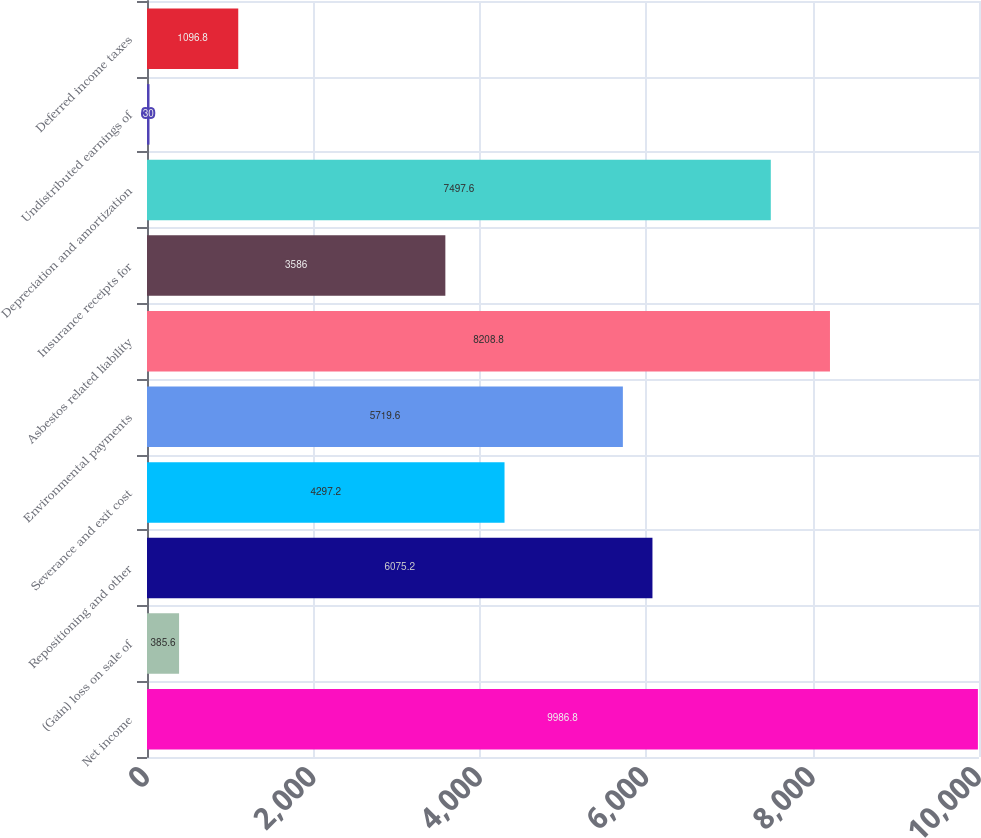Convert chart. <chart><loc_0><loc_0><loc_500><loc_500><bar_chart><fcel>Net income<fcel>(Gain) loss on sale of<fcel>Repositioning and other<fcel>Severance and exit cost<fcel>Environmental payments<fcel>Asbestos related liability<fcel>Insurance receipts for<fcel>Depreciation and amortization<fcel>Undistributed earnings of<fcel>Deferred income taxes<nl><fcel>9986.8<fcel>385.6<fcel>6075.2<fcel>4297.2<fcel>5719.6<fcel>8208.8<fcel>3586<fcel>7497.6<fcel>30<fcel>1096.8<nl></chart> 